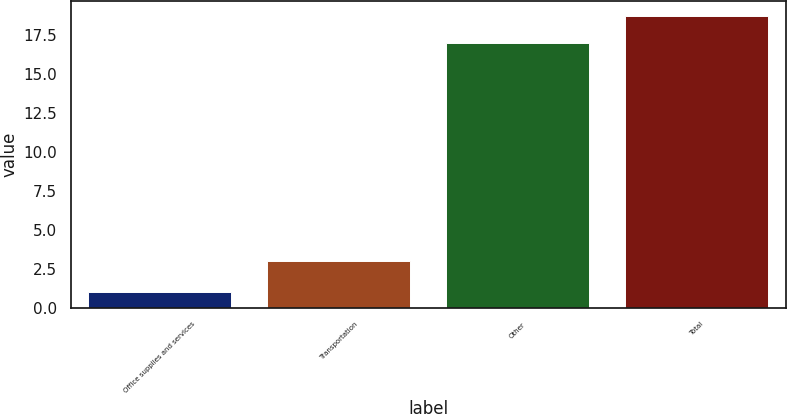Convert chart. <chart><loc_0><loc_0><loc_500><loc_500><bar_chart><fcel>Office supplies and services<fcel>Transportation<fcel>Other<fcel>Total<nl><fcel>1<fcel>3<fcel>17<fcel>18.7<nl></chart> 